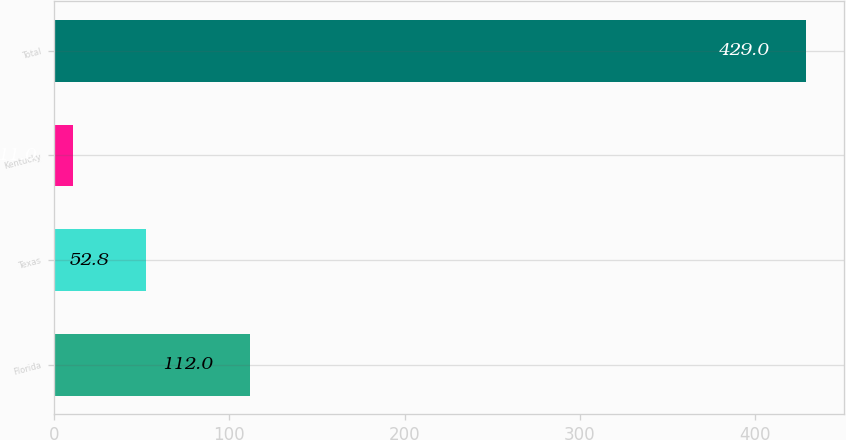<chart> <loc_0><loc_0><loc_500><loc_500><bar_chart><fcel>Florida<fcel>Texas<fcel>Kentucky<fcel>Total<nl><fcel>112<fcel>52.8<fcel>11<fcel>429<nl></chart> 